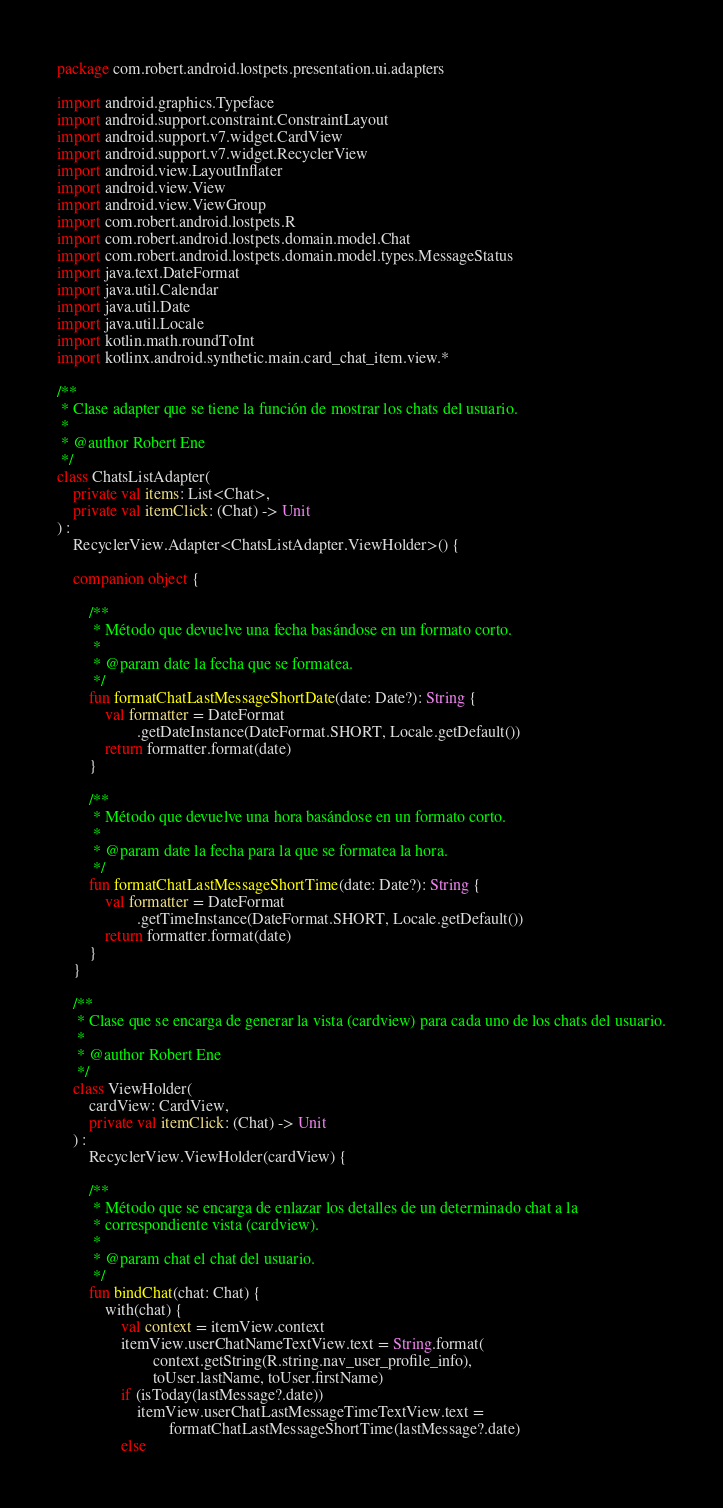Convert code to text. <code><loc_0><loc_0><loc_500><loc_500><_Kotlin_>package com.robert.android.lostpets.presentation.ui.adapters

import android.graphics.Typeface
import android.support.constraint.ConstraintLayout
import android.support.v7.widget.CardView
import android.support.v7.widget.RecyclerView
import android.view.LayoutInflater
import android.view.View
import android.view.ViewGroup
import com.robert.android.lostpets.R
import com.robert.android.lostpets.domain.model.Chat
import com.robert.android.lostpets.domain.model.types.MessageStatus
import java.text.DateFormat
import java.util.Calendar
import java.util.Date
import java.util.Locale
import kotlin.math.roundToInt
import kotlinx.android.synthetic.main.card_chat_item.view.*

/**
 * Clase adapter que se tiene la función de mostrar los chats del usuario.
 *
 * @author Robert Ene
 */
class ChatsListAdapter(
    private val items: List<Chat>,
    private val itemClick: (Chat) -> Unit
) :
    RecyclerView.Adapter<ChatsListAdapter.ViewHolder>() {

    companion object {

        /**
         * Método que devuelve una fecha basándose en un formato corto.
         *
         * @param date la fecha que se formatea.
         */
        fun formatChatLastMessageShortDate(date: Date?): String {
            val formatter = DateFormat
                    .getDateInstance(DateFormat.SHORT, Locale.getDefault())
            return formatter.format(date)
        }

        /**
         * Método que devuelve una hora basándose en un formato corto.
         *
         * @param date la fecha para la que se formatea la hora.
         */
        fun formatChatLastMessageShortTime(date: Date?): String {
            val formatter = DateFormat
                    .getTimeInstance(DateFormat.SHORT, Locale.getDefault())
            return formatter.format(date)
        }
    }

    /**
     * Clase que se encarga de generar la vista (cardview) para cada uno de los chats del usuario.
     *
     * @author Robert Ene
     */
    class ViewHolder(
        cardView: CardView,
        private val itemClick: (Chat) -> Unit
    ) :
        RecyclerView.ViewHolder(cardView) {

        /**
         * Método que se encarga de enlazar los detalles de un determinado chat a la
         * correspondiente vista (cardview).
         *
         * @param chat el chat del usuario.
         */
        fun bindChat(chat: Chat) {
            with(chat) {
                val context = itemView.context
                itemView.userChatNameTextView.text = String.format(
                        context.getString(R.string.nav_user_profile_info),
                        toUser.lastName, toUser.firstName)
                if (isToday(lastMessage?.date))
                    itemView.userChatLastMessageTimeTextView.text =
                            formatChatLastMessageShortTime(lastMessage?.date)
                else</code> 